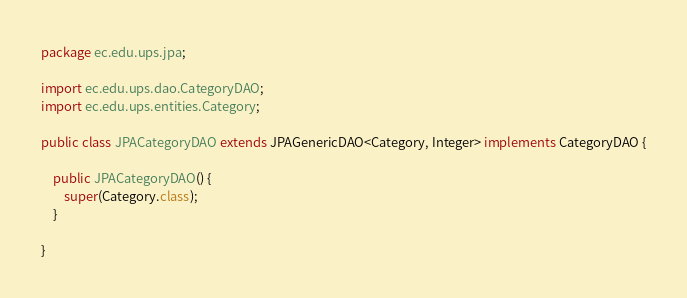<code> <loc_0><loc_0><loc_500><loc_500><_Java_>package ec.edu.ups.jpa;

import ec.edu.ups.dao.CategoryDAO;
import ec.edu.ups.entities.Category;

public class JPACategoryDAO extends JPAGenericDAO<Category, Integer> implements CategoryDAO {

	public JPACategoryDAO() {
		super(Category.class);
	}

}
</code> 